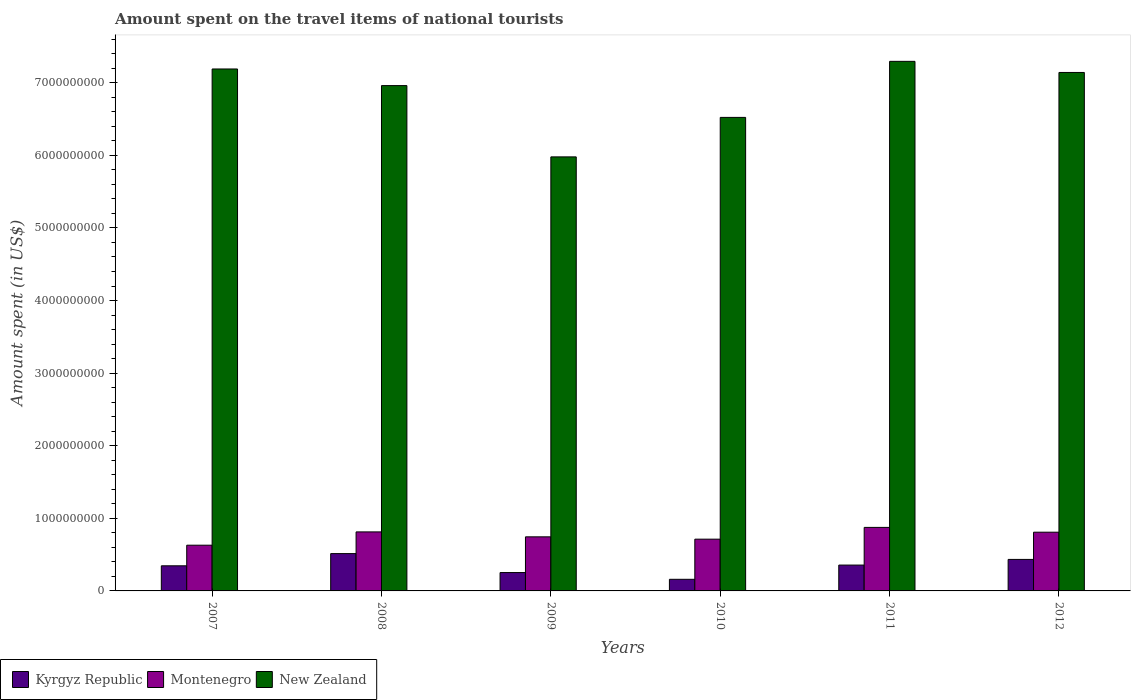How many different coloured bars are there?
Your answer should be very brief. 3. How many groups of bars are there?
Provide a short and direct response. 6. Are the number of bars per tick equal to the number of legend labels?
Offer a terse response. Yes. Are the number of bars on each tick of the X-axis equal?
Offer a terse response. Yes. How many bars are there on the 2nd tick from the right?
Make the answer very short. 3. What is the label of the 5th group of bars from the left?
Give a very brief answer. 2011. What is the amount spent on the travel items of national tourists in Montenegro in 2007?
Provide a succinct answer. 6.30e+08. Across all years, what is the maximum amount spent on the travel items of national tourists in New Zealand?
Your answer should be very brief. 7.30e+09. Across all years, what is the minimum amount spent on the travel items of national tourists in New Zealand?
Provide a succinct answer. 5.98e+09. In which year was the amount spent on the travel items of national tourists in New Zealand minimum?
Give a very brief answer. 2009. What is the total amount spent on the travel items of national tourists in New Zealand in the graph?
Offer a very short reply. 4.11e+1. What is the difference between the amount spent on the travel items of national tourists in New Zealand in 2009 and that in 2011?
Keep it short and to the point. -1.32e+09. What is the difference between the amount spent on the travel items of national tourists in New Zealand in 2008 and the amount spent on the travel items of national tourists in Montenegro in 2009?
Keep it short and to the point. 6.22e+09. What is the average amount spent on the travel items of national tourists in New Zealand per year?
Give a very brief answer. 6.85e+09. In the year 2010, what is the difference between the amount spent on the travel items of national tourists in Kyrgyz Republic and amount spent on the travel items of national tourists in New Zealand?
Offer a very short reply. -6.36e+09. What is the ratio of the amount spent on the travel items of national tourists in Montenegro in 2009 to that in 2011?
Provide a succinct answer. 0.85. Is the amount spent on the travel items of national tourists in Montenegro in 2007 less than that in 2010?
Provide a succinct answer. Yes. Is the difference between the amount spent on the travel items of national tourists in Kyrgyz Republic in 2008 and 2010 greater than the difference between the amount spent on the travel items of national tourists in New Zealand in 2008 and 2010?
Offer a terse response. No. What is the difference between the highest and the second highest amount spent on the travel items of national tourists in Kyrgyz Republic?
Make the answer very short. 8.00e+07. What is the difference between the highest and the lowest amount spent on the travel items of national tourists in Kyrgyz Republic?
Your response must be concise. 3.54e+08. What does the 2nd bar from the left in 2011 represents?
Give a very brief answer. Montenegro. What does the 1st bar from the right in 2010 represents?
Offer a terse response. New Zealand. How many bars are there?
Provide a short and direct response. 18. Are all the bars in the graph horizontal?
Your answer should be compact. No. How are the legend labels stacked?
Offer a terse response. Horizontal. What is the title of the graph?
Provide a short and direct response. Amount spent on the travel items of national tourists. What is the label or title of the X-axis?
Your answer should be very brief. Years. What is the label or title of the Y-axis?
Provide a succinct answer. Amount spent (in US$). What is the Amount spent (in US$) in Kyrgyz Republic in 2007?
Provide a short and direct response. 3.46e+08. What is the Amount spent (in US$) of Montenegro in 2007?
Offer a terse response. 6.30e+08. What is the Amount spent (in US$) in New Zealand in 2007?
Provide a short and direct response. 7.19e+09. What is the Amount spent (in US$) of Kyrgyz Republic in 2008?
Ensure brevity in your answer.  5.14e+08. What is the Amount spent (in US$) of Montenegro in 2008?
Offer a terse response. 8.13e+08. What is the Amount spent (in US$) of New Zealand in 2008?
Your response must be concise. 6.96e+09. What is the Amount spent (in US$) in Kyrgyz Republic in 2009?
Keep it short and to the point. 2.53e+08. What is the Amount spent (in US$) in Montenegro in 2009?
Offer a very short reply. 7.45e+08. What is the Amount spent (in US$) of New Zealand in 2009?
Provide a succinct answer. 5.98e+09. What is the Amount spent (in US$) of Kyrgyz Republic in 2010?
Provide a succinct answer. 1.60e+08. What is the Amount spent (in US$) in Montenegro in 2010?
Your response must be concise. 7.13e+08. What is the Amount spent (in US$) of New Zealand in 2010?
Your answer should be very brief. 6.52e+09. What is the Amount spent (in US$) in Kyrgyz Republic in 2011?
Your answer should be compact. 3.56e+08. What is the Amount spent (in US$) in Montenegro in 2011?
Your answer should be compact. 8.75e+08. What is the Amount spent (in US$) in New Zealand in 2011?
Keep it short and to the point. 7.30e+09. What is the Amount spent (in US$) in Kyrgyz Republic in 2012?
Offer a terse response. 4.34e+08. What is the Amount spent (in US$) in Montenegro in 2012?
Your answer should be compact. 8.09e+08. What is the Amount spent (in US$) of New Zealand in 2012?
Offer a very short reply. 7.14e+09. Across all years, what is the maximum Amount spent (in US$) in Kyrgyz Republic?
Your response must be concise. 5.14e+08. Across all years, what is the maximum Amount spent (in US$) of Montenegro?
Offer a very short reply. 8.75e+08. Across all years, what is the maximum Amount spent (in US$) of New Zealand?
Make the answer very short. 7.30e+09. Across all years, what is the minimum Amount spent (in US$) in Kyrgyz Republic?
Ensure brevity in your answer.  1.60e+08. Across all years, what is the minimum Amount spent (in US$) in Montenegro?
Offer a very short reply. 6.30e+08. Across all years, what is the minimum Amount spent (in US$) of New Zealand?
Provide a short and direct response. 5.98e+09. What is the total Amount spent (in US$) in Kyrgyz Republic in the graph?
Offer a very short reply. 2.06e+09. What is the total Amount spent (in US$) in Montenegro in the graph?
Your response must be concise. 4.58e+09. What is the total Amount spent (in US$) in New Zealand in the graph?
Provide a short and direct response. 4.11e+1. What is the difference between the Amount spent (in US$) in Kyrgyz Republic in 2007 and that in 2008?
Give a very brief answer. -1.68e+08. What is the difference between the Amount spent (in US$) of Montenegro in 2007 and that in 2008?
Ensure brevity in your answer.  -1.83e+08. What is the difference between the Amount spent (in US$) in New Zealand in 2007 and that in 2008?
Provide a succinct answer. 2.29e+08. What is the difference between the Amount spent (in US$) in Kyrgyz Republic in 2007 and that in 2009?
Ensure brevity in your answer.  9.30e+07. What is the difference between the Amount spent (in US$) in Montenegro in 2007 and that in 2009?
Offer a very short reply. -1.15e+08. What is the difference between the Amount spent (in US$) of New Zealand in 2007 and that in 2009?
Offer a very short reply. 1.21e+09. What is the difference between the Amount spent (in US$) of Kyrgyz Republic in 2007 and that in 2010?
Offer a very short reply. 1.86e+08. What is the difference between the Amount spent (in US$) of Montenegro in 2007 and that in 2010?
Make the answer very short. -8.30e+07. What is the difference between the Amount spent (in US$) in New Zealand in 2007 and that in 2010?
Ensure brevity in your answer.  6.67e+08. What is the difference between the Amount spent (in US$) of Kyrgyz Republic in 2007 and that in 2011?
Offer a very short reply. -1.00e+07. What is the difference between the Amount spent (in US$) in Montenegro in 2007 and that in 2011?
Your answer should be compact. -2.45e+08. What is the difference between the Amount spent (in US$) in New Zealand in 2007 and that in 2011?
Keep it short and to the point. -1.05e+08. What is the difference between the Amount spent (in US$) in Kyrgyz Republic in 2007 and that in 2012?
Provide a succinct answer. -8.80e+07. What is the difference between the Amount spent (in US$) of Montenegro in 2007 and that in 2012?
Ensure brevity in your answer.  -1.79e+08. What is the difference between the Amount spent (in US$) in New Zealand in 2007 and that in 2012?
Provide a succinct answer. 4.80e+07. What is the difference between the Amount spent (in US$) of Kyrgyz Republic in 2008 and that in 2009?
Offer a terse response. 2.61e+08. What is the difference between the Amount spent (in US$) of Montenegro in 2008 and that in 2009?
Your response must be concise. 6.80e+07. What is the difference between the Amount spent (in US$) in New Zealand in 2008 and that in 2009?
Offer a very short reply. 9.82e+08. What is the difference between the Amount spent (in US$) of Kyrgyz Republic in 2008 and that in 2010?
Keep it short and to the point. 3.54e+08. What is the difference between the Amount spent (in US$) of New Zealand in 2008 and that in 2010?
Give a very brief answer. 4.38e+08. What is the difference between the Amount spent (in US$) of Kyrgyz Republic in 2008 and that in 2011?
Your answer should be very brief. 1.58e+08. What is the difference between the Amount spent (in US$) of Montenegro in 2008 and that in 2011?
Provide a short and direct response. -6.20e+07. What is the difference between the Amount spent (in US$) in New Zealand in 2008 and that in 2011?
Offer a terse response. -3.34e+08. What is the difference between the Amount spent (in US$) of Kyrgyz Republic in 2008 and that in 2012?
Your response must be concise. 8.00e+07. What is the difference between the Amount spent (in US$) of New Zealand in 2008 and that in 2012?
Keep it short and to the point. -1.81e+08. What is the difference between the Amount spent (in US$) in Kyrgyz Republic in 2009 and that in 2010?
Make the answer very short. 9.30e+07. What is the difference between the Amount spent (in US$) in Montenegro in 2009 and that in 2010?
Your answer should be very brief. 3.20e+07. What is the difference between the Amount spent (in US$) in New Zealand in 2009 and that in 2010?
Ensure brevity in your answer.  -5.44e+08. What is the difference between the Amount spent (in US$) in Kyrgyz Republic in 2009 and that in 2011?
Your response must be concise. -1.03e+08. What is the difference between the Amount spent (in US$) of Montenegro in 2009 and that in 2011?
Your answer should be compact. -1.30e+08. What is the difference between the Amount spent (in US$) in New Zealand in 2009 and that in 2011?
Give a very brief answer. -1.32e+09. What is the difference between the Amount spent (in US$) of Kyrgyz Republic in 2009 and that in 2012?
Make the answer very short. -1.81e+08. What is the difference between the Amount spent (in US$) in Montenegro in 2009 and that in 2012?
Your response must be concise. -6.40e+07. What is the difference between the Amount spent (in US$) of New Zealand in 2009 and that in 2012?
Provide a succinct answer. -1.16e+09. What is the difference between the Amount spent (in US$) of Kyrgyz Republic in 2010 and that in 2011?
Keep it short and to the point. -1.96e+08. What is the difference between the Amount spent (in US$) of Montenegro in 2010 and that in 2011?
Give a very brief answer. -1.62e+08. What is the difference between the Amount spent (in US$) of New Zealand in 2010 and that in 2011?
Your response must be concise. -7.72e+08. What is the difference between the Amount spent (in US$) in Kyrgyz Republic in 2010 and that in 2012?
Keep it short and to the point. -2.74e+08. What is the difference between the Amount spent (in US$) of Montenegro in 2010 and that in 2012?
Offer a terse response. -9.60e+07. What is the difference between the Amount spent (in US$) in New Zealand in 2010 and that in 2012?
Give a very brief answer. -6.19e+08. What is the difference between the Amount spent (in US$) of Kyrgyz Republic in 2011 and that in 2012?
Give a very brief answer. -7.80e+07. What is the difference between the Amount spent (in US$) in Montenegro in 2011 and that in 2012?
Provide a succinct answer. 6.60e+07. What is the difference between the Amount spent (in US$) of New Zealand in 2011 and that in 2012?
Your response must be concise. 1.53e+08. What is the difference between the Amount spent (in US$) in Kyrgyz Republic in 2007 and the Amount spent (in US$) in Montenegro in 2008?
Your response must be concise. -4.67e+08. What is the difference between the Amount spent (in US$) of Kyrgyz Republic in 2007 and the Amount spent (in US$) of New Zealand in 2008?
Make the answer very short. -6.62e+09. What is the difference between the Amount spent (in US$) in Montenegro in 2007 and the Amount spent (in US$) in New Zealand in 2008?
Make the answer very short. -6.33e+09. What is the difference between the Amount spent (in US$) of Kyrgyz Republic in 2007 and the Amount spent (in US$) of Montenegro in 2009?
Ensure brevity in your answer.  -3.99e+08. What is the difference between the Amount spent (in US$) of Kyrgyz Republic in 2007 and the Amount spent (in US$) of New Zealand in 2009?
Make the answer very short. -5.63e+09. What is the difference between the Amount spent (in US$) in Montenegro in 2007 and the Amount spent (in US$) in New Zealand in 2009?
Your response must be concise. -5.35e+09. What is the difference between the Amount spent (in US$) in Kyrgyz Republic in 2007 and the Amount spent (in US$) in Montenegro in 2010?
Your answer should be compact. -3.67e+08. What is the difference between the Amount spent (in US$) in Kyrgyz Republic in 2007 and the Amount spent (in US$) in New Zealand in 2010?
Provide a succinct answer. -6.18e+09. What is the difference between the Amount spent (in US$) in Montenegro in 2007 and the Amount spent (in US$) in New Zealand in 2010?
Offer a terse response. -5.89e+09. What is the difference between the Amount spent (in US$) of Kyrgyz Republic in 2007 and the Amount spent (in US$) of Montenegro in 2011?
Your answer should be very brief. -5.29e+08. What is the difference between the Amount spent (in US$) in Kyrgyz Republic in 2007 and the Amount spent (in US$) in New Zealand in 2011?
Your answer should be very brief. -6.95e+09. What is the difference between the Amount spent (in US$) in Montenegro in 2007 and the Amount spent (in US$) in New Zealand in 2011?
Give a very brief answer. -6.66e+09. What is the difference between the Amount spent (in US$) in Kyrgyz Republic in 2007 and the Amount spent (in US$) in Montenegro in 2012?
Give a very brief answer. -4.63e+08. What is the difference between the Amount spent (in US$) in Kyrgyz Republic in 2007 and the Amount spent (in US$) in New Zealand in 2012?
Make the answer very short. -6.80e+09. What is the difference between the Amount spent (in US$) of Montenegro in 2007 and the Amount spent (in US$) of New Zealand in 2012?
Your answer should be very brief. -6.51e+09. What is the difference between the Amount spent (in US$) of Kyrgyz Republic in 2008 and the Amount spent (in US$) of Montenegro in 2009?
Your response must be concise. -2.31e+08. What is the difference between the Amount spent (in US$) of Kyrgyz Republic in 2008 and the Amount spent (in US$) of New Zealand in 2009?
Give a very brief answer. -5.46e+09. What is the difference between the Amount spent (in US$) in Montenegro in 2008 and the Amount spent (in US$) in New Zealand in 2009?
Ensure brevity in your answer.  -5.17e+09. What is the difference between the Amount spent (in US$) of Kyrgyz Republic in 2008 and the Amount spent (in US$) of Montenegro in 2010?
Keep it short and to the point. -1.99e+08. What is the difference between the Amount spent (in US$) of Kyrgyz Republic in 2008 and the Amount spent (in US$) of New Zealand in 2010?
Ensure brevity in your answer.  -6.01e+09. What is the difference between the Amount spent (in US$) of Montenegro in 2008 and the Amount spent (in US$) of New Zealand in 2010?
Provide a succinct answer. -5.71e+09. What is the difference between the Amount spent (in US$) in Kyrgyz Republic in 2008 and the Amount spent (in US$) in Montenegro in 2011?
Offer a terse response. -3.61e+08. What is the difference between the Amount spent (in US$) in Kyrgyz Republic in 2008 and the Amount spent (in US$) in New Zealand in 2011?
Provide a short and direct response. -6.78e+09. What is the difference between the Amount spent (in US$) in Montenegro in 2008 and the Amount spent (in US$) in New Zealand in 2011?
Provide a short and direct response. -6.48e+09. What is the difference between the Amount spent (in US$) of Kyrgyz Republic in 2008 and the Amount spent (in US$) of Montenegro in 2012?
Give a very brief answer. -2.95e+08. What is the difference between the Amount spent (in US$) of Kyrgyz Republic in 2008 and the Amount spent (in US$) of New Zealand in 2012?
Ensure brevity in your answer.  -6.63e+09. What is the difference between the Amount spent (in US$) of Montenegro in 2008 and the Amount spent (in US$) of New Zealand in 2012?
Offer a terse response. -6.33e+09. What is the difference between the Amount spent (in US$) in Kyrgyz Republic in 2009 and the Amount spent (in US$) in Montenegro in 2010?
Make the answer very short. -4.60e+08. What is the difference between the Amount spent (in US$) of Kyrgyz Republic in 2009 and the Amount spent (in US$) of New Zealand in 2010?
Your response must be concise. -6.27e+09. What is the difference between the Amount spent (in US$) of Montenegro in 2009 and the Amount spent (in US$) of New Zealand in 2010?
Ensure brevity in your answer.  -5.78e+09. What is the difference between the Amount spent (in US$) of Kyrgyz Republic in 2009 and the Amount spent (in US$) of Montenegro in 2011?
Your answer should be compact. -6.22e+08. What is the difference between the Amount spent (in US$) in Kyrgyz Republic in 2009 and the Amount spent (in US$) in New Zealand in 2011?
Provide a succinct answer. -7.04e+09. What is the difference between the Amount spent (in US$) in Montenegro in 2009 and the Amount spent (in US$) in New Zealand in 2011?
Your answer should be very brief. -6.55e+09. What is the difference between the Amount spent (in US$) of Kyrgyz Republic in 2009 and the Amount spent (in US$) of Montenegro in 2012?
Give a very brief answer. -5.56e+08. What is the difference between the Amount spent (in US$) of Kyrgyz Republic in 2009 and the Amount spent (in US$) of New Zealand in 2012?
Your answer should be very brief. -6.89e+09. What is the difference between the Amount spent (in US$) in Montenegro in 2009 and the Amount spent (in US$) in New Zealand in 2012?
Make the answer very short. -6.40e+09. What is the difference between the Amount spent (in US$) in Kyrgyz Republic in 2010 and the Amount spent (in US$) in Montenegro in 2011?
Offer a very short reply. -7.15e+08. What is the difference between the Amount spent (in US$) in Kyrgyz Republic in 2010 and the Amount spent (in US$) in New Zealand in 2011?
Offer a very short reply. -7.14e+09. What is the difference between the Amount spent (in US$) of Montenegro in 2010 and the Amount spent (in US$) of New Zealand in 2011?
Make the answer very short. -6.58e+09. What is the difference between the Amount spent (in US$) in Kyrgyz Republic in 2010 and the Amount spent (in US$) in Montenegro in 2012?
Ensure brevity in your answer.  -6.49e+08. What is the difference between the Amount spent (in US$) in Kyrgyz Republic in 2010 and the Amount spent (in US$) in New Zealand in 2012?
Keep it short and to the point. -6.98e+09. What is the difference between the Amount spent (in US$) in Montenegro in 2010 and the Amount spent (in US$) in New Zealand in 2012?
Provide a succinct answer. -6.43e+09. What is the difference between the Amount spent (in US$) in Kyrgyz Republic in 2011 and the Amount spent (in US$) in Montenegro in 2012?
Keep it short and to the point. -4.53e+08. What is the difference between the Amount spent (in US$) of Kyrgyz Republic in 2011 and the Amount spent (in US$) of New Zealand in 2012?
Your answer should be very brief. -6.79e+09. What is the difference between the Amount spent (in US$) of Montenegro in 2011 and the Amount spent (in US$) of New Zealand in 2012?
Make the answer very short. -6.27e+09. What is the average Amount spent (in US$) in Kyrgyz Republic per year?
Offer a very short reply. 3.44e+08. What is the average Amount spent (in US$) in Montenegro per year?
Your answer should be very brief. 7.64e+08. What is the average Amount spent (in US$) of New Zealand per year?
Your answer should be compact. 6.85e+09. In the year 2007, what is the difference between the Amount spent (in US$) of Kyrgyz Republic and Amount spent (in US$) of Montenegro?
Provide a short and direct response. -2.84e+08. In the year 2007, what is the difference between the Amount spent (in US$) in Kyrgyz Republic and Amount spent (in US$) in New Zealand?
Your response must be concise. -6.84e+09. In the year 2007, what is the difference between the Amount spent (in US$) of Montenegro and Amount spent (in US$) of New Zealand?
Keep it short and to the point. -6.56e+09. In the year 2008, what is the difference between the Amount spent (in US$) in Kyrgyz Republic and Amount spent (in US$) in Montenegro?
Your response must be concise. -2.99e+08. In the year 2008, what is the difference between the Amount spent (in US$) of Kyrgyz Republic and Amount spent (in US$) of New Zealand?
Give a very brief answer. -6.45e+09. In the year 2008, what is the difference between the Amount spent (in US$) in Montenegro and Amount spent (in US$) in New Zealand?
Your answer should be compact. -6.15e+09. In the year 2009, what is the difference between the Amount spent (in US$) in Kyrgyz Republic and Amount spent (in US$) in Montenegro?
Give a very brief answer. -4.92e+08. In the year 2009, what is the difference between the Amount spent (in US$) of Kyrgyz Republic and Amount spent (in US$) of New Zealand?
Offer a terse response. -5.73e+09. In the year 2009, what is the difference between the Amount spent (in US$) of Montenegro and Amount spent (in US$) of New Zealand?
Your response must be concise. -5.23e+09. In the year 2010, what is the difference between the Amount spent (in US$) in Kyrgyz Republic and Amount spent (in US$) in Montenegro?
Give a very brief answer. -5.53e+08. In the year 2010, what is the difference between the Amount spent (in US$) of Kyrgyz Republic and Amount spent (in US$) of New Zealand?
Provide a short and direct response. -6.36e+09. In the year 2010, what is the difference between the Amount spent (in US$) in Montenegro and Amount spent (in US$) in New Zealand?
Ensure brevity in your answer.  -5.81e+09. In the year 2011, what is the difference between the Amount spent (in US$) of Kyrgyz Republic and Amount spent (in US$) of Montenegro?
Your response must be concise. -5.19e+08. In the year 2011, what is the difference between the Amount spent (in US$) of Kyrgyz Republic and Amount spent (in US$) of New Zealand?
Keep it short and to the point. -6.94e+09. In the year 2011, what is the difference between the Amount spent (in US$) in Montenegro and Amount spent (in US$) in New Zealand?
Keep it short and to the point. -6.42e+09. In the year 2012, what is the difference between the Amount spent (in US$) of Kyrgyz Republic and Amount spent (in US$) of Montenegro?
Offer a very short reply. -3.75e+08. In the year 2012, what is the difference between the Amount spent (in US$) in Kyrgyz Republic and Amount spent (in US$) in New Zealand?
Offer a very short reply. -6.71e+09. In the year 2012, what is the difference between the Amount spent (in US$) in Montenegro and Amount spent (in US$) in New Zealand?
Your response must be concise. -6.33e+09. What is the ratio of the Amount spent (in US$) of Kyrgyz Republic in 2007 to that in 2008?
Keep it short and to the point. 0.67. What is the ratio of the Amount spent (in US$) of Montenegro in 2007 to that in 2008?
Offer a terse response. 0.77. What is the ratio of the Amount spent (in US$) of New Zealand in 2007 to that in 2008?
Offer a terse response. 1.03. What is the ratio of the Amount spent (in US$) in Kyrgyz Republic in 2007 to that in 2009?
Provide a short and direct response. 1.37. What is the ratio of the Amount spent (in US$) in Montenegro in 2007 to that in 2009?
Your answer should be very brief. 0.85. What is the ratio of the Amount spent (in US$) in New Zealand in 2007 to that in 2009?
Keep it short and to the point. 1.2. What is the ratio of the Amount spent (in US$) in Kyrgyz Republic in 2007 to that in 2010?
Keep it short and to the point. 2.16. What is the ratio of the Amount spent (in US$) of Montenegro in 2007 to that in 2010?
Provide a short and direct response. 0.88. What is the ratio of the Amount spent (in US$) in New Zealand in 2007 to that in 2010?
Your answer should be very brief. 1.1. What is the ratio of the Amount spent (in US$) in Kyrgyz Republic in 2007 to that in 2011?
Your answer should be very brief. 0.97. What is the ratio of the Amount spent (in US$) of Montenegro in 2007 to that in 2011?
Provide a short and direct response. 0.72. What is the ratio of the Amount spent (in US$) of New Zealand in 2007 to that in 2011?
Offer a very short reply. 0.99. What is the ratio of the Amount spent (in US$) of Kyrgyz Republic in 2007 to that in 2012?
Ensure brevity in your answer.  0.8. What is the ratio of the Amount spent (in US$) in Montenegro in 2007 to that in 2012?
Your answer should be compact. 0.78. What is the ratio of the Amount spent (in US$) of Kyrgyz Republic in 2008 to that in 2009?
Provide a succinct answer. 2.03. What is the ratio of the Amount spent (in US$) in Montenegro in 2008 to that in 2009?
Offer a terse response. 1.09. What is the ratio of the Amount spent (in US$) in New Zealand in 2008 to that in 2009?
Offer a very short reply. 1.16. What is the ratio of the Amount spent (in US$) in Kyrgyz Republic in 2008 to that in 2010?
Make the answer very short. 3.21. What is the ratio of the Amount spent (in US$) of Montenegro in 2008 to that in 2010?
Your response must be concise. 1.14. What is the ratio of the Amount spent (in US$) in New Zealand in 2008 to that in 2010?
Your answer should be compact. 1.07. What is the ratio of the Amount spent (in US$) in Kyrgyz Republic in 2008 to that in 2011?
Offer a very short reply. 1.44. What is the ratio of the Amount spent (in US$) in Montenegro in 2008 to that in 2011?
Your response must be concise. 0.93. What is the ratio of the Amount spent (in US$) in New Zealand in 2008 to that in 2011?
Provide a succinct answer. 0.95. What is the ratio of the Amount spent (in US$) of Kyrgyz Republic in 2008 to that in 2012?
Your response must be concise. 1.18. What is the ratio of the Amount spent (in US$) of Montenegro in 2008 to that in 2012?
Your answer should be very brief. 1. What is the ratio of the Amount spent (in US$) in New Zealand in 2008 to that in 2012?
Give a very brief answer. 0.97. What is the ratio of the Amount spent (in US$) in Kyrgyz Republic in 2009 to that in 2010?
Make the answer very short. 1.58. What is the ratio of the Amount spent (in US$) of Montenegro in 2009 to that in 2010?
Offer a very short reply. 1.04. What is the ratio of the Amount spent (in US$) of New Zealand in 2009 to that in 2010?
Keep it short and to the point. 0.92. What is the ratio of the Amount spent (in US$) of Kyrgyz Republic in 2009 to that in 2011?
Your answer should be very brief. 0.71. What is the ratio of the Amount spent (in US$) of Montenegro in 2009 to that in 2011?
Give a very brief answer. 0.85. What is the ratio of the Amount spent (in US$) of New Zealand in 2009 to that in 2011?
Provide a succinct answer. 0.82. What is the ratio of the Amount spent (in US$) of Kyrgyz Republic in 2009 to that in 2012?
Provide a short and direct response. 0.58. What is the ratio of the Amount spent (in US$) of Montenegro in 2009 to that in 2012?
Provide a short and direct response. 0.92. What is the ratio of the Amount spent (in US$) of New Zealand in 2009 to that in 2012?
Your answer should be very brief. 0.84. What is the ratio of the Amount spent (in US$) of Kyrgyz Republic in 2010 to that in 2011?
Your answer should be compact. 0.45. What is the ratio of the Amount spent (in US$) in Montenegro in 2010 to that in 2011?
Ensure brevity in your answer.  0.81. What is the ratio of the Amount spent (in US$) in New Zealand in 2010 to that in 2011?
Give a very brief answer. 0.89. What is the ratio of the Amount spent (in US$) of Kyrgyz Republic in 2010 to that in 2012?
Keep it short and to the point. 0.37. What is the ratio of the Amount spent (in US$) in Montenegro in 2010 to that in 2012?
Keep it short and to the point. 0.88. What is the ratio of the Amount spent (in US$) of New Zealand in 2010 to that in 2012?
Your answer should be very brief. 0.91. What is the ratio of the Amount spent (in US$) of Kyrgyz Republic in 2011 to that in 2012?
Offer a very short reply. 0.82. What is the ratio of the Amount spent (in US$) of Montenegro in 2011 to that in 2012?
Offer a very short reply. 1.08. What is the ratio of the Amount spent (in US$) in New Zealand in 2011 to that in 2012?
Keep it short and to the point. 1.02. What is the difference between the highest and the second highest Amount spent (in US$) in Kyrgyz Republic?
Keep it short and to the point. 8.00e+07. What is the difference between the highest and the second highest Amount spent (in US$) in Montenegro?
Make the answer very short. 6.20e+07. What is the difference between the highest and the second highest Amount spent (in US$) of New Zealand?
Your response must be concise. 1.05e+08. What is the difference between the highest and the lowest Amount spent (in US$) in Kyrgyz Republic?
Keep it short and to the point. 3.54e+08. What is the difference between the highest and the lowest Amount spent (in US$) of Montenegro?
Your answer should be very brief. 2.45e+08. What is the difference between the highest and the lowest Amount spent (in US$) of New Zealand?
Your response must be concise. 1.32e+09. 